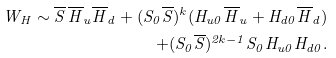Convert formula to latex. <formula><loc_0><loc_0><loc_500><loc_500>W _ { H } \sim { \overline { S } } \, { \overline { H } _ { u } } { \overline { H } _ { d } } + ( S _ { 0 } { \overline { S } } ) ^ { k } ( H _ { u 0 } { \overline { H } _ { u } } + H _ { d 0 } { \overline { H } _ { d } } ) \\ + ( S _ { 0 } { \overline { S } } ) ^ { 2 k - 1 } S _ { 0 } H _ { u 0 } H _ { d 0 } .</formula> 